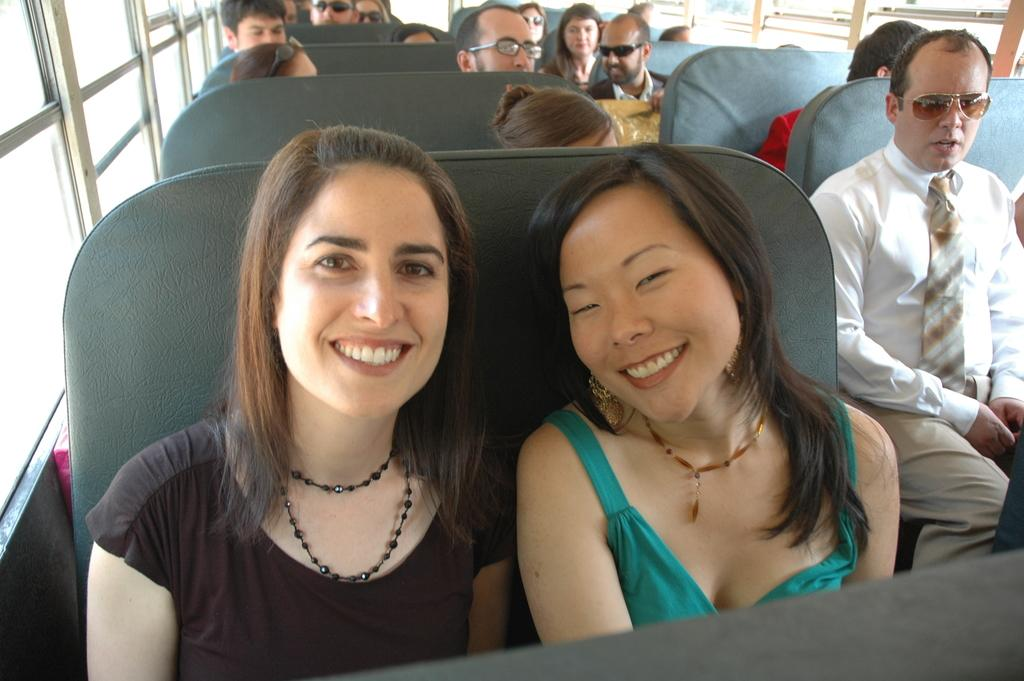What are the persons in the image doing? The persons in the image are sitting in the bus. What can be seen through the windows in the image? The provided facts do not mention anything visible through the windows, so we cannot answer that question. What type of chance does the volcano have to erupt in the image? There is no volcano present in the image, so it is not possible to determine the chance of it erupting. Is there a club visible in the image? There is no mention of a club in the provided facts, so we cannot answer that question. 